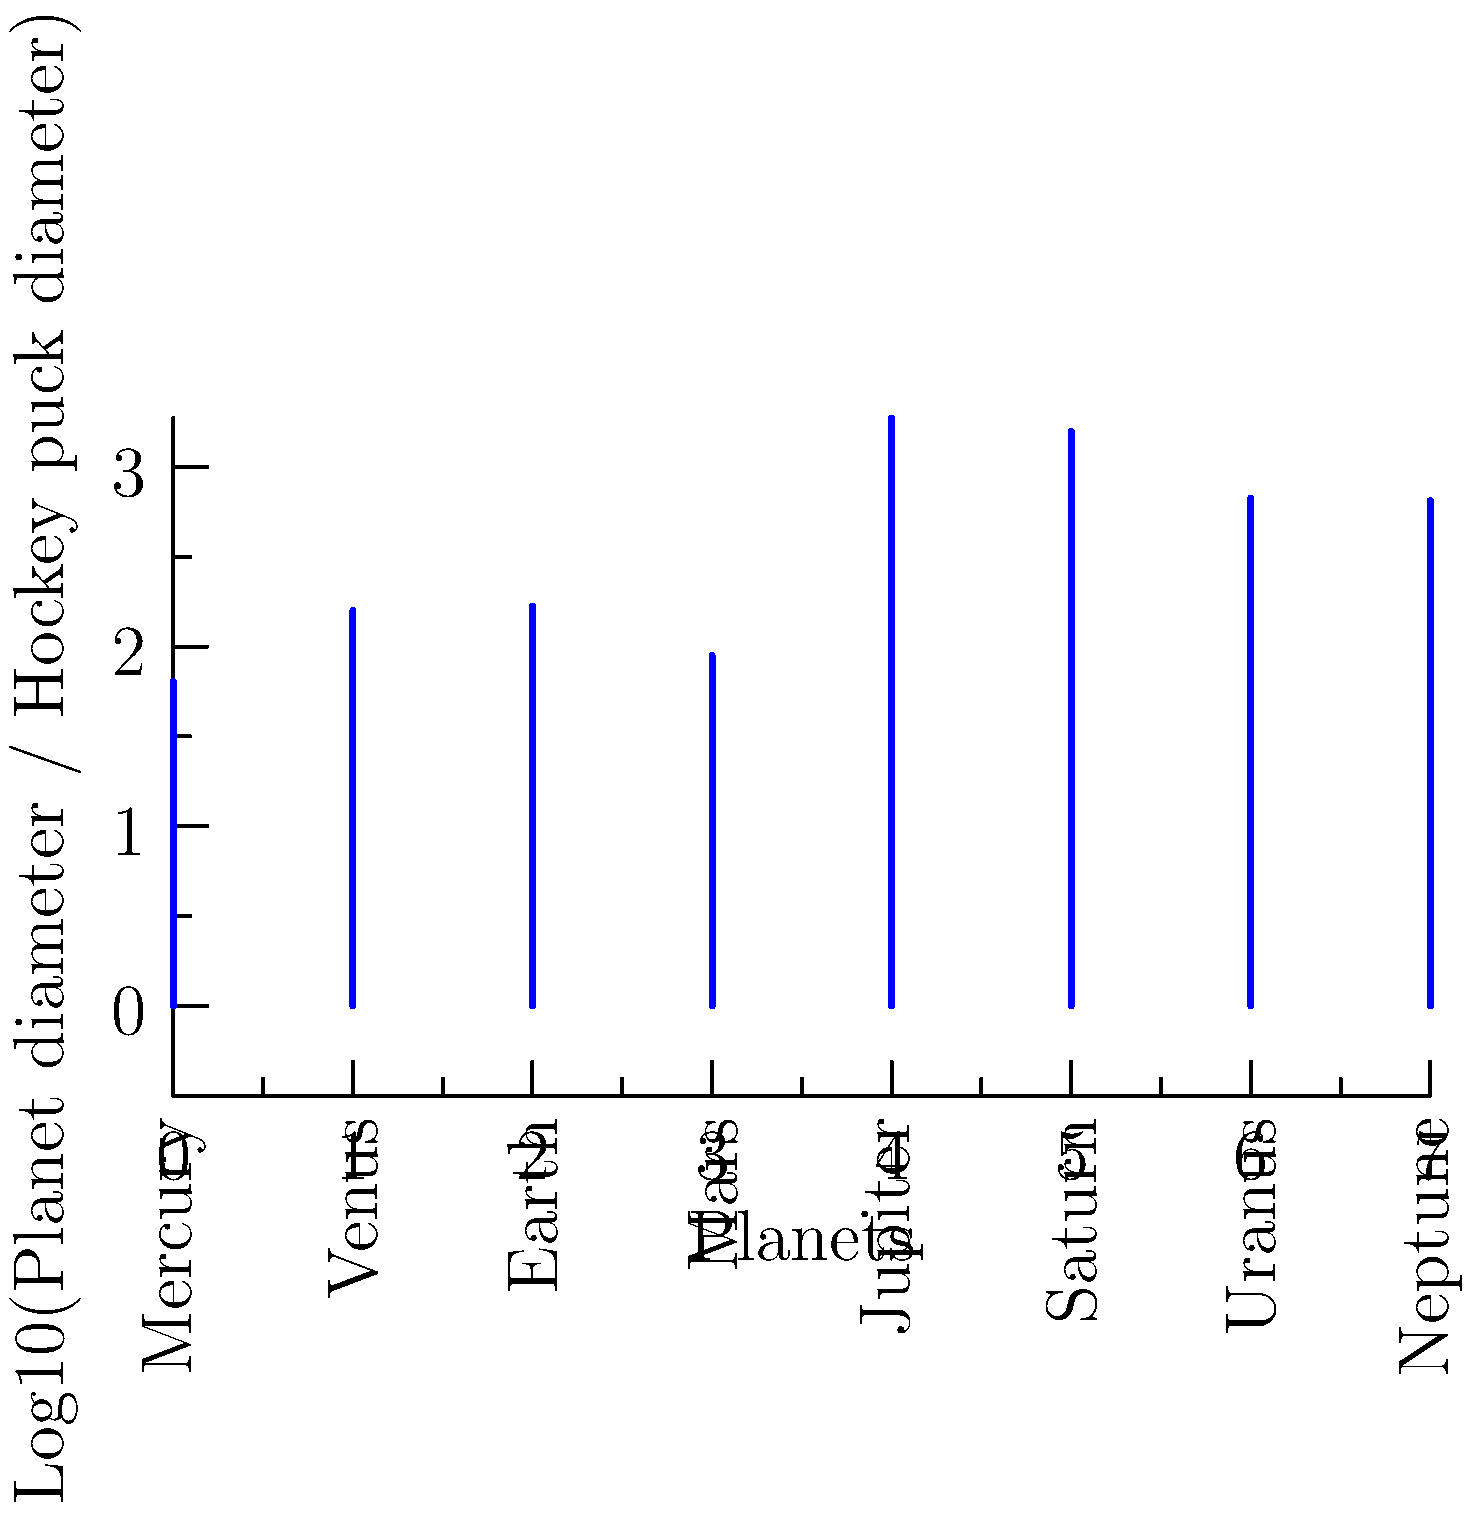As a hockey player, you're familiar with the standard size of a hockey puck. If we were to compare the diameters of planets in our solar system to a hockey puck, which planet would have the greatest ratio of its diameter to that of a hockey puck? To solve this problem, let's follow these steps:

1. Recall that a standard hockey puck has a diameter of 76.2 mm (3 inches).

2. Compare the diameters of each planet to the hockey puck:
   - Mercury: 4,879 km
   - Venus: 12,104 km
   - Earth: 12,756 km
   - Mars: 6,792 km
   - Jupiter: 142,984 km
   - Saturn: 120,536 km
   - Uranus: 51,118 km
   - Neptune: 49,528 km

3. Calculate the ratio of each planet's diameter to the hockey puck's diameter:
   $\text{Ratio} = \frac{\text{Planet diameter (mm)}}{\text{Hockey puck diameter (mm)}}$

4. Convert planet diameters to mm:
   Mercury: $4,879,000 \text{ mm}$
   Venus: $12,104,000 \text{ mm}$
   Earth: $12,756,000 \text{ mm}$
   Mars: $6,792,000 \text{ mm}$
   Jupiter: $142,984,000 \text{ mm}$
   Saturn: $120,536,000 \text{ mm}$
   Uranus: $51,118,000 \text{ mm}$
   Neptune: $49,528,000 \text{ mm}$

5. Calculate ratios:
   Mercury: $4,879,000 / 76.2 \approx 64,028$
   Venus: $12,104,000 / 76.2 \approx 158,845$
   Earth: $12,756,000 / 76.2 \approx 167,402$
   Mars: $6,792,000 / 76.2 \approx 89,134$
   Jupiter: $142,984,000 / 76.2 \approx 1,876,430$
   Saturn: $120,536,000 / 76.2 \approx 1,581,838$
   Uranus: $51,118,000 / 76.2 \approx 670,840$
   Neptune: $49,528,000 / 76.2 \approx 650,236$

6. Identify the largest ratio: Jupiter at approximately 1,876,430.

The graph shows the logarithmic scale of these ratios, with Jupiter clearly having the highest bar.
Answer: Jupiter 